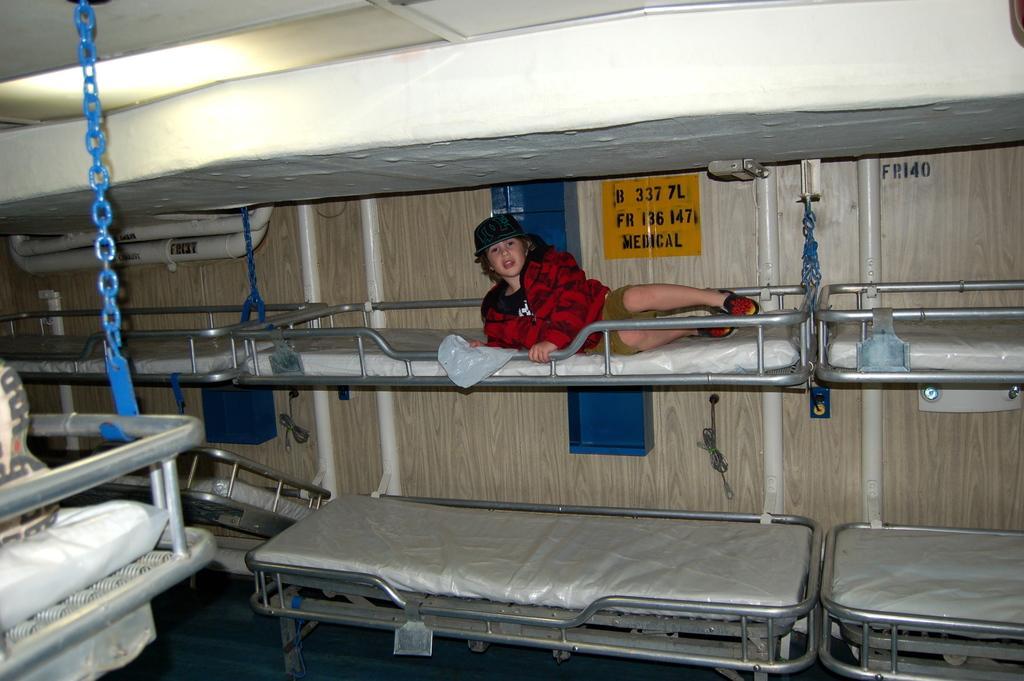Please provide a concise description of this image. In this picture I can observe a kid laying on the bed. I can observe a dormitory in this picture. In the background there is a wall. 